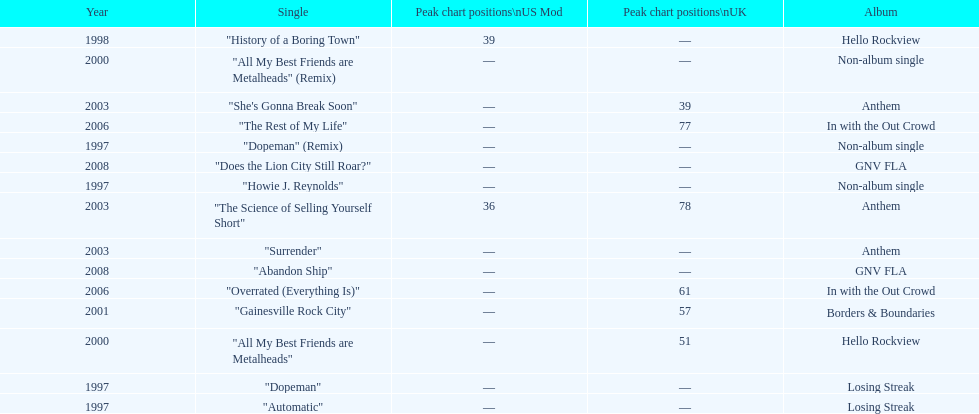Name one other single that was on the losing streak album besides "dopeman". "Automatic". 